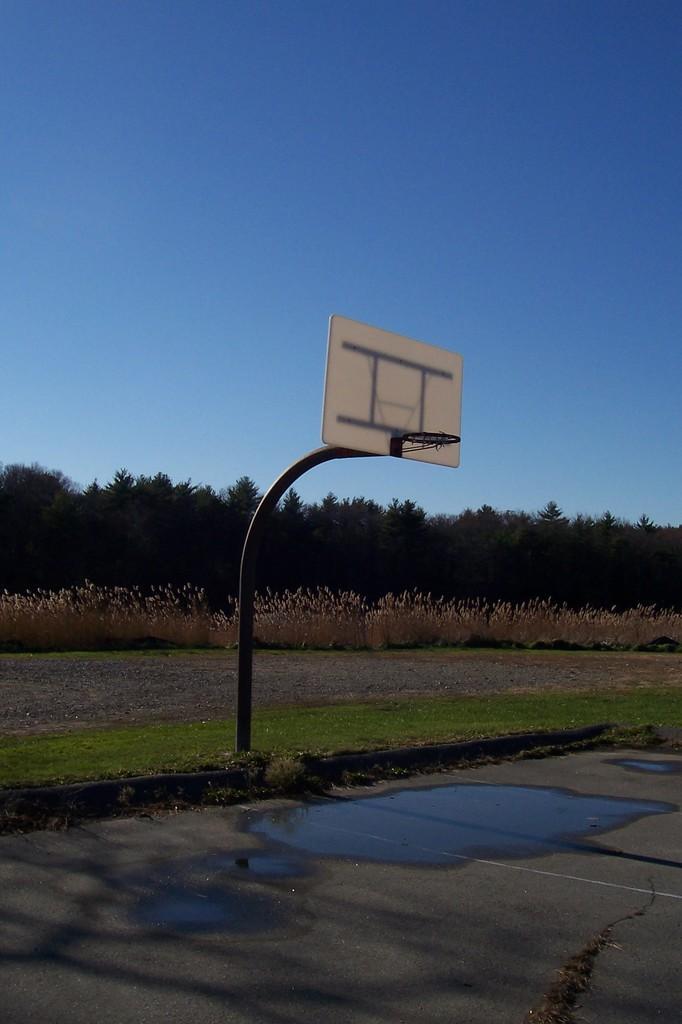How would you summarize this image in a sentence or two? At the bottom of the image there is a floor with water. There is a pole with basketball board with basket. On the ground there is grass and also there are small plants and also there are trees. At the top of the image there is a sky. 